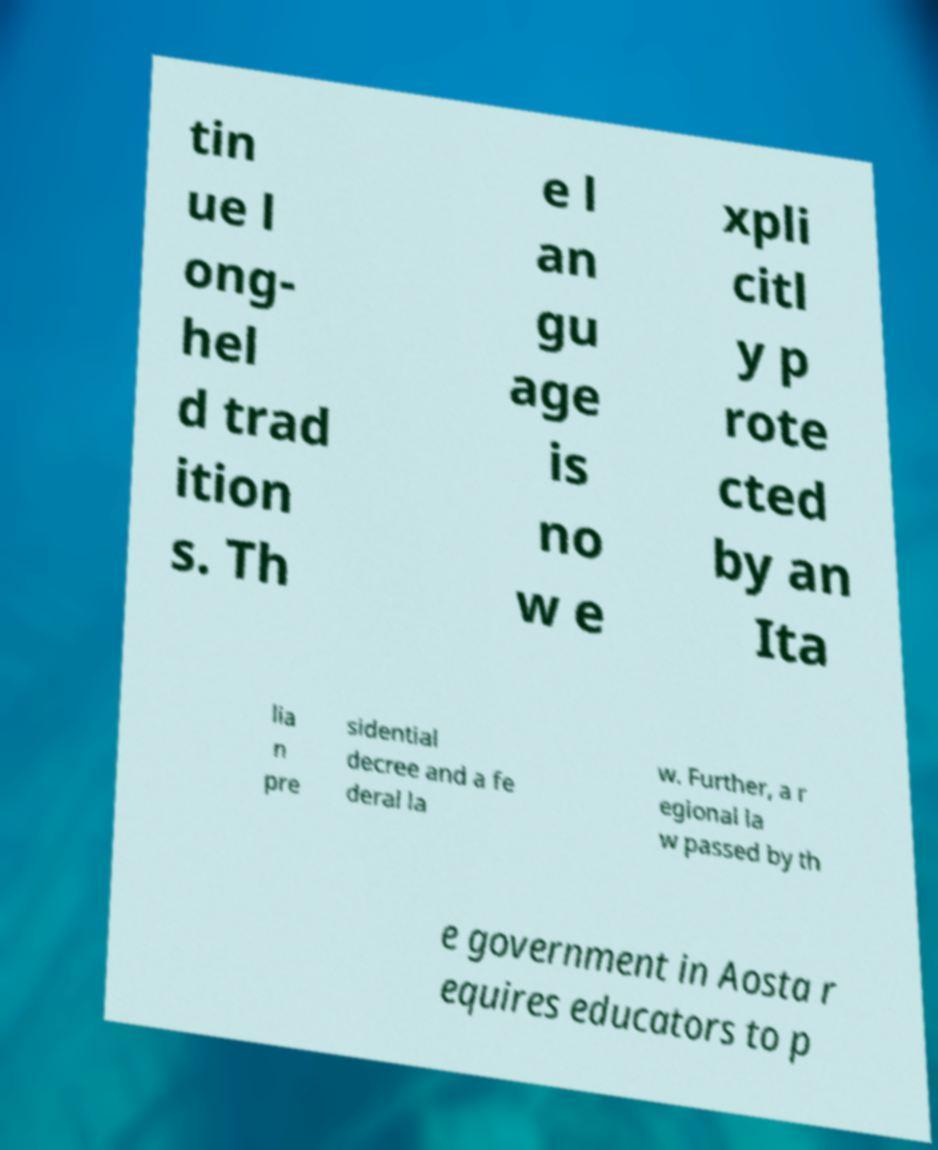Please read and relay the text visible in this image. What does it say? tin ue l ong- hel d trad ition s. Th e l an gu age is no w e xpli citl y p rote cted by an Ita lia n pre sidential decree and a fe deral la w. Further, a r egional la w passed by th e government in Aosta r equires educators to p 